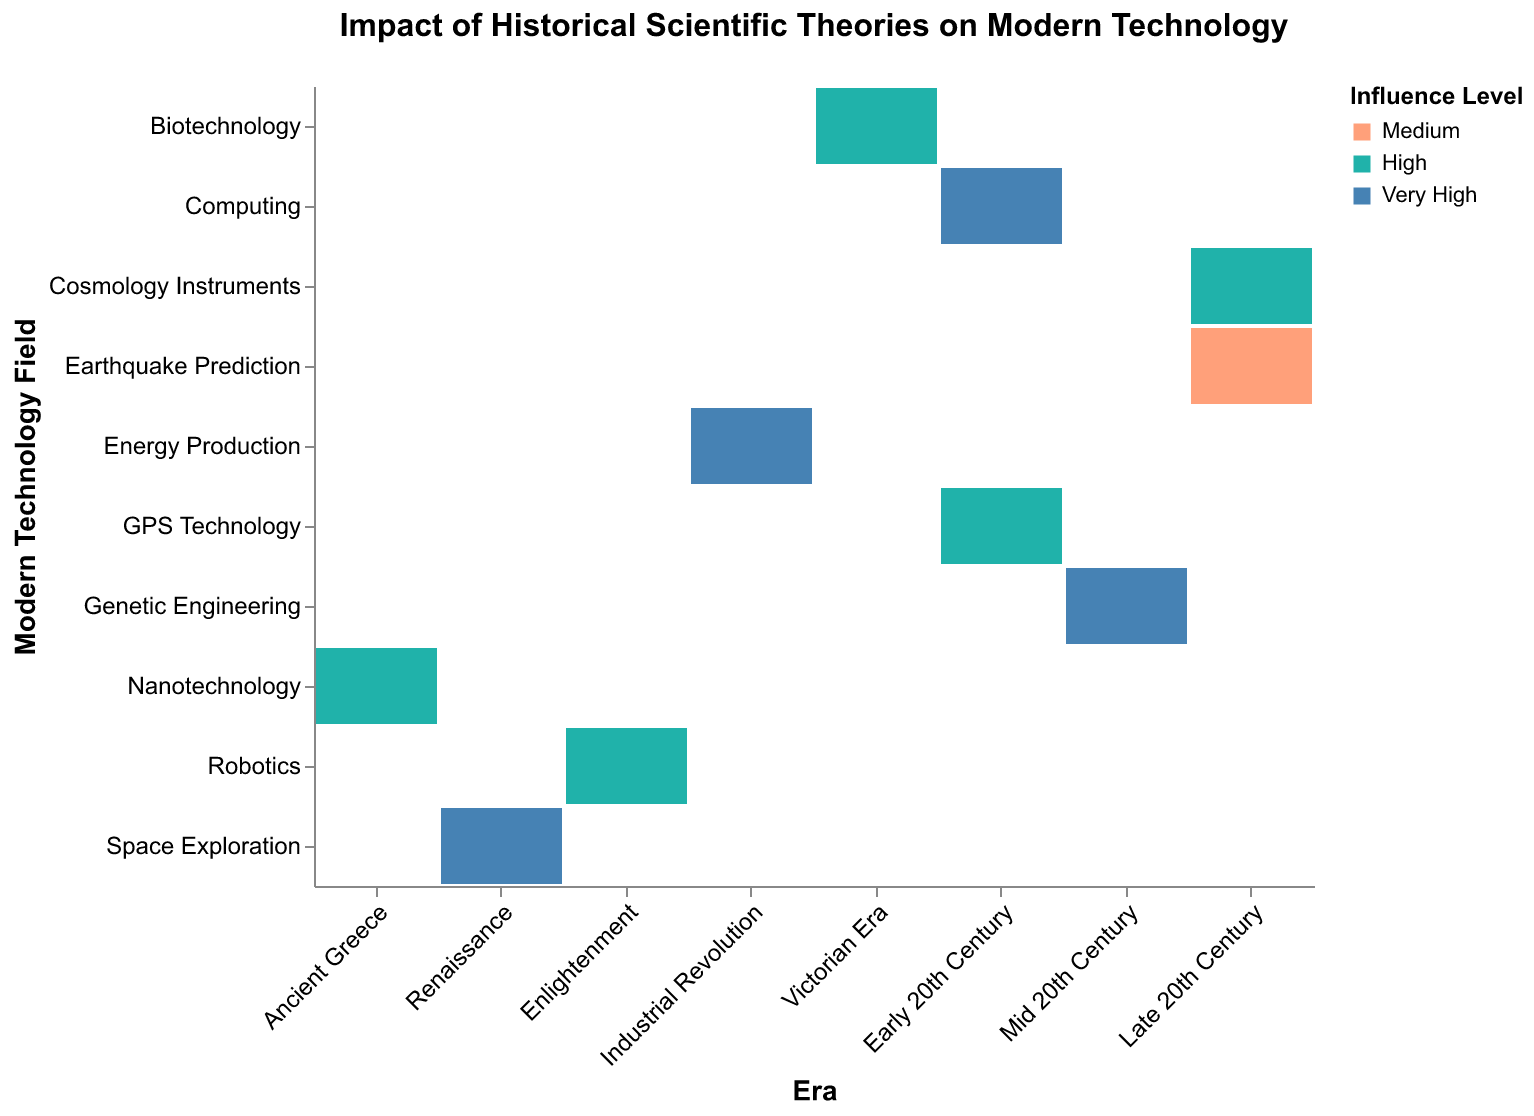What era contributed the theory of Heliocentrism? The figure has a vertical axis representing Modern Technology Fields and a horizontal axis representing Eras. By looking for Heliocentrism on the Modern Technology Field axis, we see it aligns with the Renaissance era on the Era axis.
Answer: Renaissance Which modern technology field is influenced by Newtonian Mechanics? The plot shows Newtonian Mechanics in the vertical "Modern Technology Field" axis intersecting with Robotics on the horizontal "Era" axis.
Answer: Robotics What is the influence level of the theory of Quantum Mechanics on modern technology? In the figure, Quantum Mechanics intersects with Computing in the Modern Technology Field. The color representing this intersection indicates the Influence Level, which is Very High.
Answer: Very High How many theories have an influence level of "Very High"? By counting the segments shaded with the color representing "Very High", we see there are four segments for Heliocentrism, Thermodynamics, Quantum Mechanics, and DNA Structure.
Answer: 4 Which theory in the Late 20th Century has the lowest influence level, and what field does it influence? The Late 20th Century column contains Plate Tectonics and Big Bang Theory. Plate Tectonics uses a color representing Medium, which is lower than High. Plate Tectonics influences Earthquake Prediction.
Answer: Plate Tectonics, Earthquake Prediction Which era has the highest diversity in the influence level of its theories? Diverse influence levels are identified by multiple colors within an Era's column. The Late 20th Century era shows Medium, High, and Very High influence levels, highlighting its diversity.
Answer: Late 20th Century Did any era's theories influence more than one modern technology field? Early 20th Century shows intersections with Computing (Quantum Mechanics) and GPS Technology (General Relativity), indicating multiple fields influenced.
Answer: Early 20th Century What is the most common influence level across all eras and theories? By visually surveying the colors representing Influence Levels across the plot, it is apparent the color for High influence (associated with "#20B2AA") is the most frequent.
Answer: High 